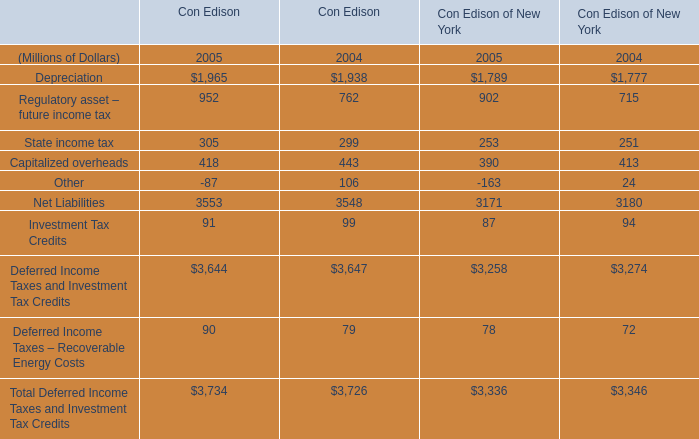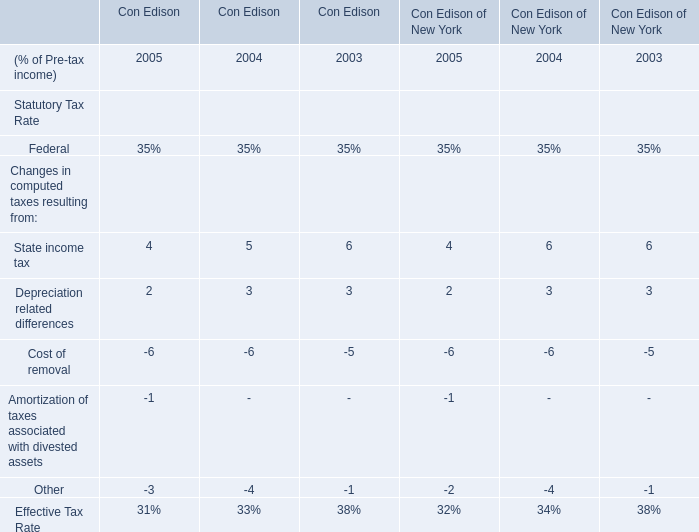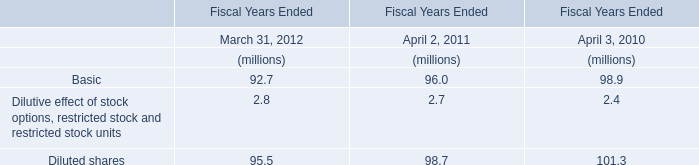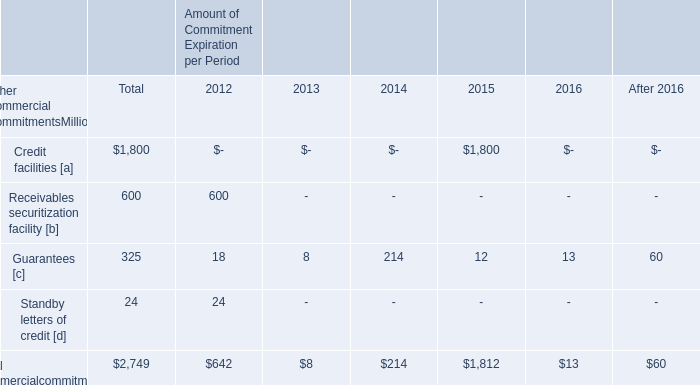What is the growing rate of Depreciation of Con Edison in the years with the least Capitalized overheads? 
Computations: ((1965 - 1938) / 1938)
Answer: 0.01393. 